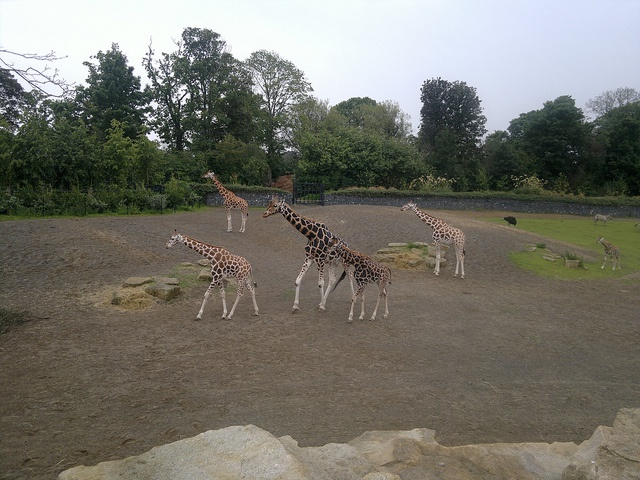Describe the objects in this image and their specific colors. I can see giraffe in white, gray, black, and darkgray tones, giraffe in white, gray, darkgray, and maroon tones, giraffe in white, gray, and black tones, giraffe in white, darkgray, and gray tones, and giraffe in white, gray, darkgray, and maroon tones in this image. 